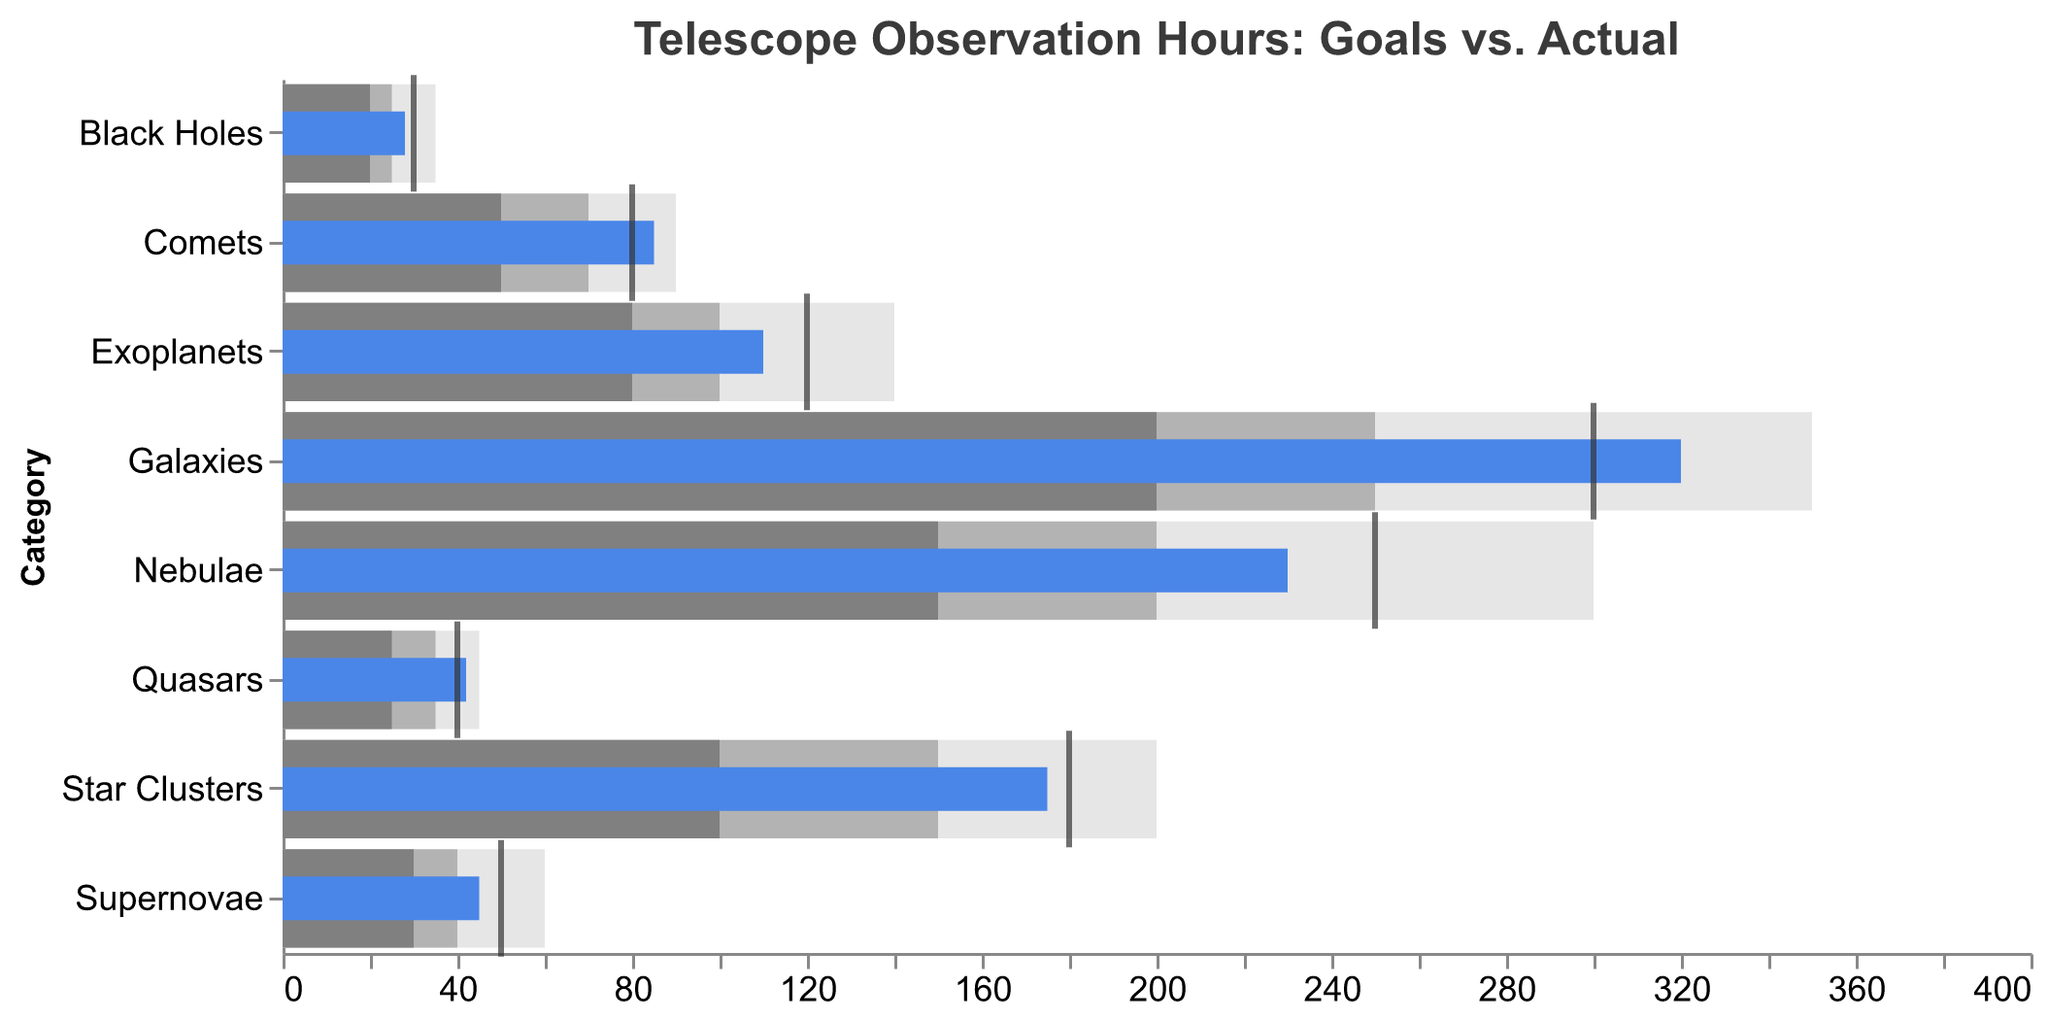What's the title of the figure? The title is displayed at the top of the figure and typically provides a summary of what the figure illustrates.
Answer: Telescope Observation Hours: Goals vs. Actual What are the three different ranges represented by the shaded bars for Nebulae? The three different ranges for Nebulae are represented by the three shades of gray. These values are found in the data for Nebulae: Range1 (150 hours), Range2 (200 hours), and Range3 (300 hours).
Answer: 150, 200, 300 For which celestial object is the actual observation hours the highest? By scanning through the “Actual” blue bars, we can see that Galaxies has the highest actual observation hours at 320 hours.
Answer: Galaxies By how much does the actual observation hours for Exoplanets fall short of the goal? The goal for Exoplanets is 120 hours, and the actual observation is 110 hours. Subtracting the Actual from the Goal gives the shortfall: 120 - 110 = 10 hours.
Answer: 10 hours Which celestial objects exceeded their observation goals? By comparing the Actual (blue bar) and the Goal (tick mark) for each object, we see that Galaxies, Comets, and Quasars have actual hours greater than their goals.
Answer: Galaxies, Comets, Quasars Which celestial object is closest to achieving its goal, excluding those that exceeded their goals? Star Clusters are closest to achieving their goal out of those that fell short, with a goal of 180 hours and an actual observation of 175 hours. The difference is 5 hours.
Answer: Star Clusters What is the gap between the lowest range and the actual observation for Black Holes? The lowest range for Black Holes (Range1) is 20 hours, and the actual observation is 28 hours. Subtracting the range1 from the actual gives the gap: 28 - 20 = 8 hours.
Answer: 8 hours Compare the goal for Nebulae and Exoplanets. Which is greater and by how much? The goal for Nebulae is 250 hours, and for Exoplanets is 120 hours. Subtracting the Exoplanets' goal from the Nebulae's goal gives the difference: 250 - 120 = 130 hours.
Answer: Nebulae by 130 hours Between Comets and Quasars, which celestial object has more actual observation hours? The actual observation hours for Comets is 85 hours, and for Quasars is 42 hours. Comparing these two values, Comets have more actual observation hours.
Answer: Comets 